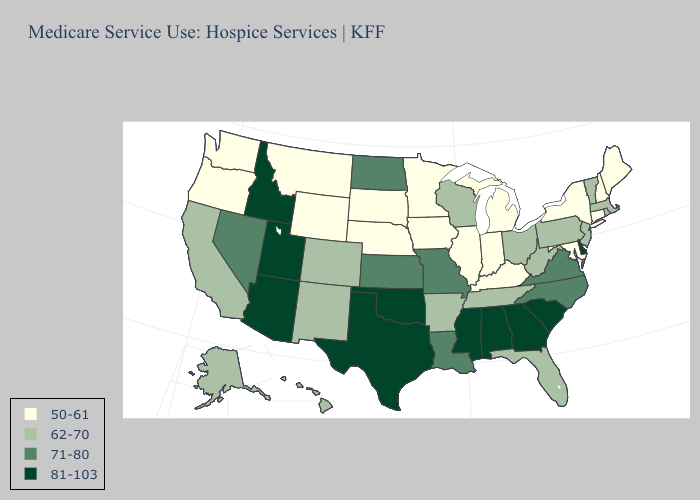Name the states that have a value in the range 62-70?
Write a very short answer. Alaska, Arkansas, California, Colorado, Florida, Hawaii, Massachusetts, New Jersey, New Mexico, Ohio, Pennsylvania, Rhode Island, Tennessee, Vermont, West Virginia, Wisconsin. Does North Dakota have the lowest value in the MidWest?
Write a very short answer. No. Does the first symbol in the legend represent the smallest category?
Be succinct. Yes. Does Delaware have the highest value in the USA?
Keep it brief. Yes. Does Vermont have the same value as Maryland?
Answer briefly. No. Name the states that have a value in the range 71-80?
Give a very brief answer. Kansas, Louisiana, Missouri, Nevada, North Carolina, North Dakota, Virginia. What is the highest value in states that border South Dakota?
Be succinct. 71-80. Does Texas have the highest value in the USA?
Concise answer only. Yes. What is the highest value in the MidWest ?
Concise answer only. 71-80. What is the value of Texas?
Keep it brief. 81-103. How many symbols are there in the legend?
Concise answer only. 4. What is the lowest value in the USA?
Write a very short answer. 50-61. What is the value of Texas?
Quick response, please. 81-103. What is the value of Rhode Island?
Short answer required. 62-70. What is the lowest value in the USA?
Write a very short answer. 50-61. 